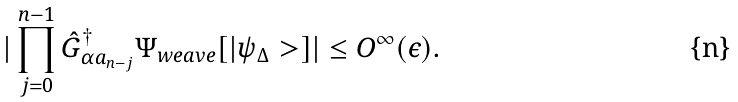<formula> <loc_0><loc_0><loc_500><loc_500>| \prod _ { j = 0 } ^ { n - 1 } { \hat { G } } ^ { \dagger } _ { \alpha a _ { n - j } } \Psi _ { w e a v e } [ | \psi _ { \Delta } > ] | \leq O ^ { \infty } ( \epsilon ) .</formula> 